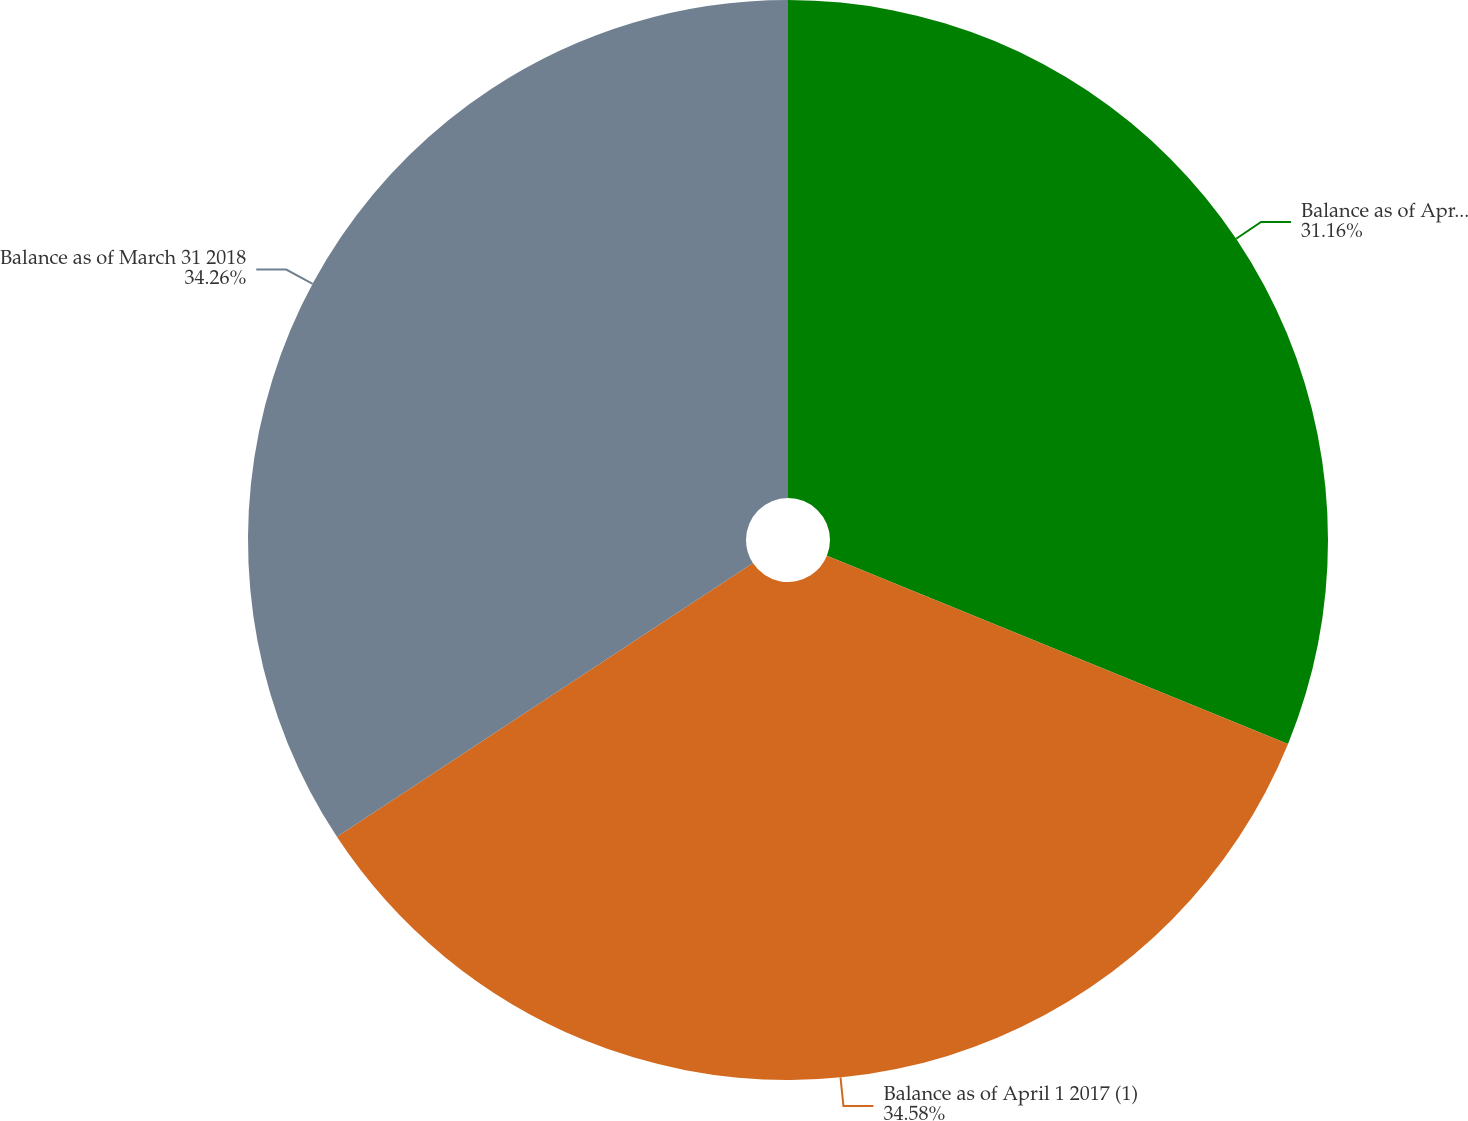Convert chart. <chart><loc_0><loc_0><loc_500><loc_500><pie_chart><fcel>Balance as of April 2 2016 (1)<fcel>Balance as of April 1 2017 (1)<fcel>Balance as of March 31 2018<nl><fcel>31.16%<fcel>34.57%<fcel>34.26%<nl></chart> 